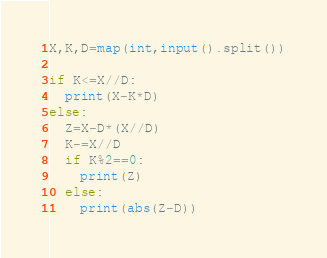<code> <loc_0><loc_0><loc_500><loc_500><_Python_>X,K,D=map(int,input().split())

if K<=X//D:
  print(X-K*D)
else:
  Z=X-D*(X//D)
  K-=X//D
  if K%2==0:
    print(Z)
  else:
    print(abs(Z-D))</code> 